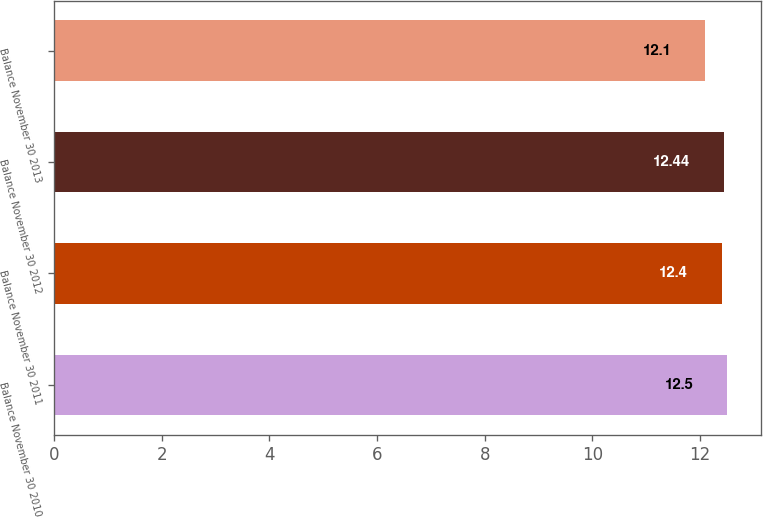Convert chart to OTSL. <chart><loc_0><loc_0><loc_500><loc_500><bar_chart><fcel>Balance November 30 2010<fcel>Balance November 30 2011<fcel>Balance November 30 2012<fcel>Balance November 30 2013<nl><fcel>12.5<fcel>12.4<fcel>12.44<fcel>12.1<nl></chart> 